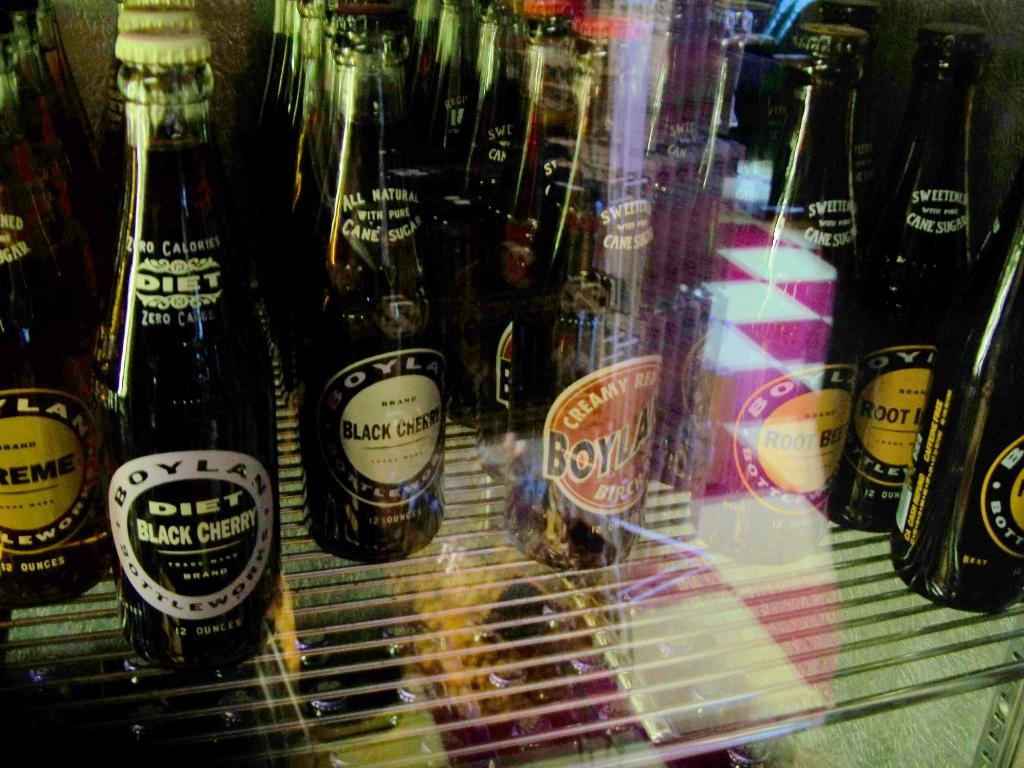<image>
Summarize the visual content of the image. Some glass bottles of soda sitting on a shelf, including both diet and regular black cherry flavors among them. 